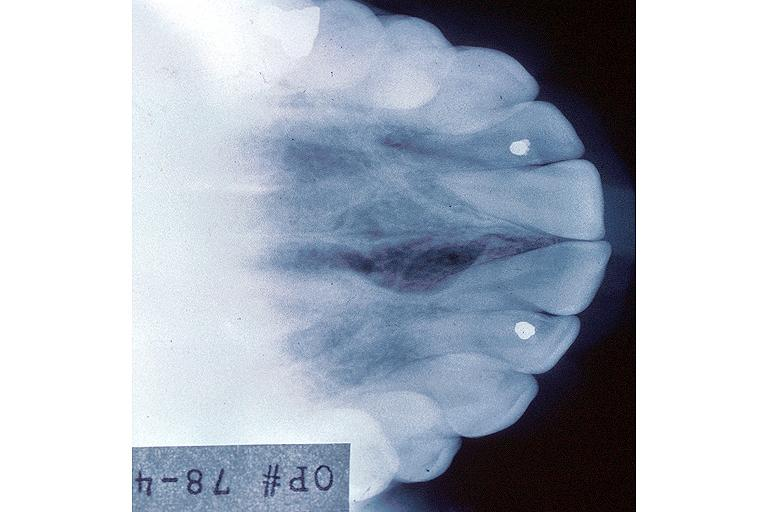s oral present?
Answer the question using a single word or phrase. Yes 